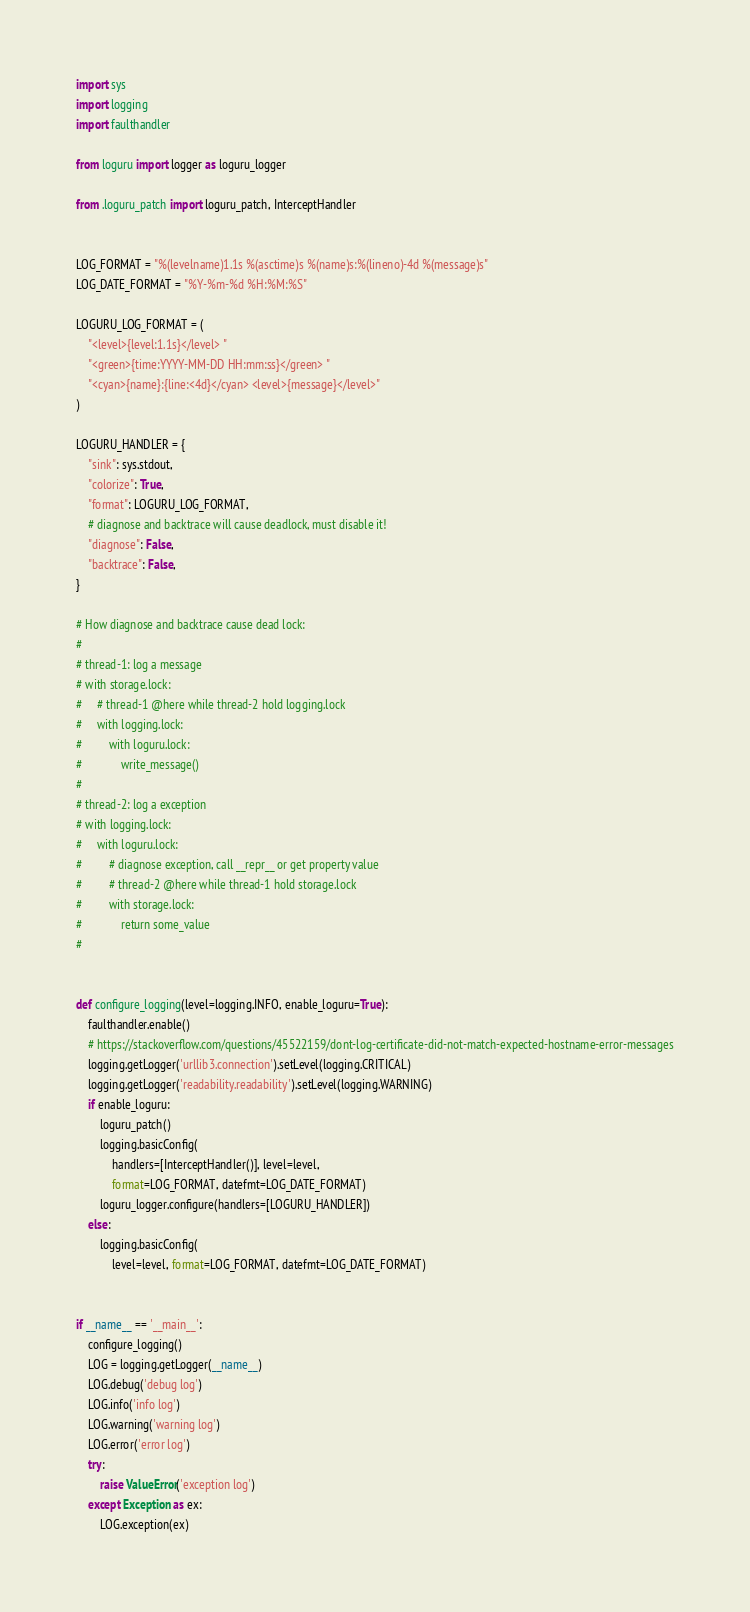<code> <loc_0><loc_0><loc_500><loc_500><_Python_>import sys
import logging
import faulthandler

from loguru import logger as loguru_logger

from .loguru_patch import loguru_patch, InterceptHandler


LOG_FORMAT = "%(levelname)1.1s %(asctime)s %(name)s:%(lineno)-4d %(message)s"
LOG_DATE_FORMAT = "%Y-%m-%d %H:%M:%S"

LOGURU_LOG_FORMAT = (
    "<level>{level:1.1s}</level> "
    "<green>{time:YYYY-MM-DD HH:mm:ss}</green> "
    "<cyan>{name}:{line:<4d}</cyan> <level>{message}</level>"
)

LOGURU_HANDLER = {
    "sink": sys.stdout,
    "colorize": True,
    "format": LOGURU_LOG_FORMAT,
    # diagnose and backtrace will cause deadlock, must disable it!
    "diagnose": False,
    "backtrace": False,
}

# How diagnose and backtrace cause dead lock:
#
# thread-1: log a message
# with storage.lock:
#     # thread-1 @here while thread-2 hold logging.lock
#     with logging.lock:
#         with loguru.lock:
#             write_message()
#
# thread-2: log a exception
# with logging.lock:
#     with loguru.lock:
#         # diagnose exception, call __repr__ or get property value
#         # thread-2 @here while thread-1 hold storage.lock
#         with storage.lock:
#             return some_value
#


def configure_logging(level=logging.INFO, enable_loguru=True):
    faulthandler.enable()
    # https://stackoverflow.com/questions/45522159/dont-log-certificate-did-not-match-expected-hostname-error-messages
    logging.getLogger('urllib3.connection').setLevel(logging.CRITICAL)
    logging.getLogger('readability.readability').setLevel(logging.WARNING)
    if enable_loguru:
        loguru_patch()
        logging.basicConfig(
            handlers=[InterceptHandler()], level=level,
            format=LOG_FORMAT, datefmt=LOG_DATE_FORMAT)
        loguru_logger.configure(handlers=[LOGURU_HANDLER])
    else:
        logging.basicConfig(
            level=level, format=LOG_FORMAT, datefmt=LOG_DATE_FORMAT)


if __name__ == '__main__':
    configure_logging()
    LOG = logging.getLogger(__name__)
    LOG.debug('debug log')
    LOG.info('info log')
    LOG.warning('warning log')
    LOG.error('error log')
    try:
        raise ValueError('exception log')
    except Exception as ex:
        LOG.exception(ex)
</code> 